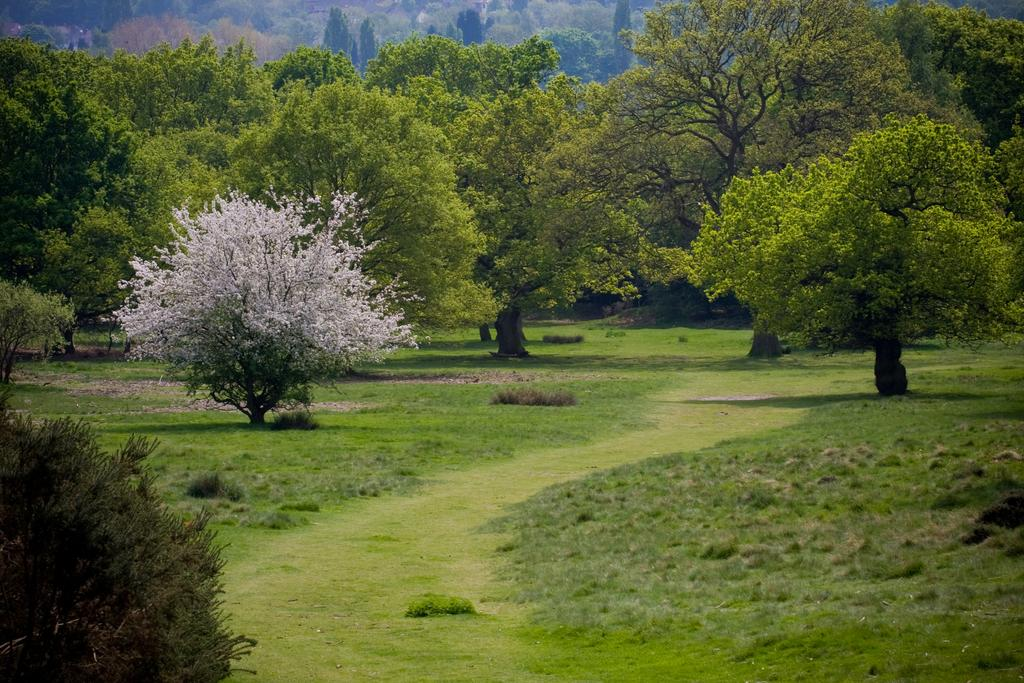What type of vegetation can be seen in the image? There is grass in the image. What can be seen in the background of the image? There are trees in the background of the image. What type of note is being distributed by the flag in the image? There is no flag or note present in the image; it only features grass and trees. 